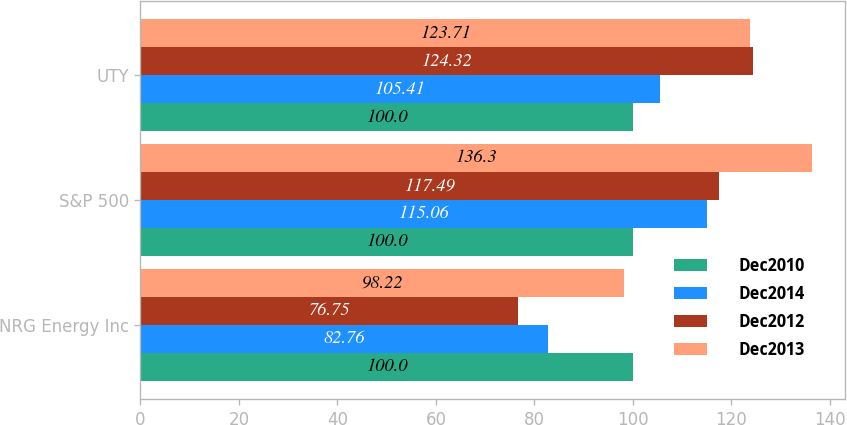Convert chart. <chart><loc_0><loc_0><loc_500><loc_500><stacked_bar_chart><ecel><fcel>NRG Energy Inc<fcel>S&P 500<fcel>UTY<nl><fcel>Dec2010<fcel>100<fcel>100<fcel>100<nl><fcel>Dec2014<fcel>82.76<fcel>115.06<fcel>105.41<nl><fcel>Dec2012<fcel>76.75<fcel>117.49<fcel>124.32<nl><fcel>Dec2013<fcel>98.22<fcel>136.3<fcel>123.71<nl></chart> 